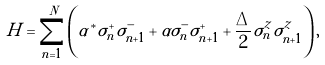<formula> <loc_0><loc_0><loc_500><loc_500>H = \sum _ { n = 1 } ^ { N } \left ( \alpha ^ { * } \sigma _ { n } ^ { + } \sigma _ { n + 1 } ^ { - } + \alpha \sigma _ { n } ^ { - } \sigma _ { n + 1 } ^ { + } + \frac { \Delta } { 2 } \sigma _ { n } ^ { z } \sigma _ { n + 1 } ^ { z } \right ) ,</formula> 